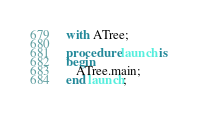<code> <loc_0><loc_0><loc_500><loc_500><_Ada_>with ATree;

procedure launch is
begin 
   ATree.main; 
end launch;
</code> 